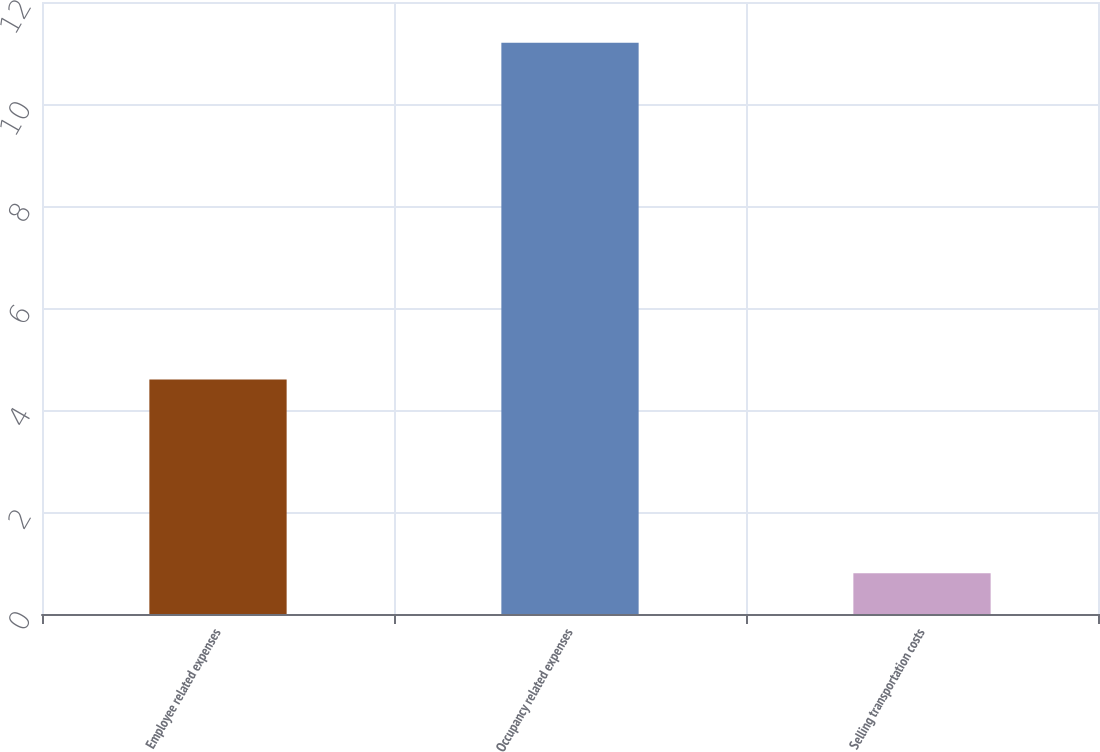<chart> <loc_0><loc_0><loc_500><loc_500><bar_chart><fcel>Employee related expenses<fcel>Occupancy related expenses<fcel>Selling transportation costs<nl><fcel>4.6<fcel>11.2<fcel>0.8<nl></chart> 